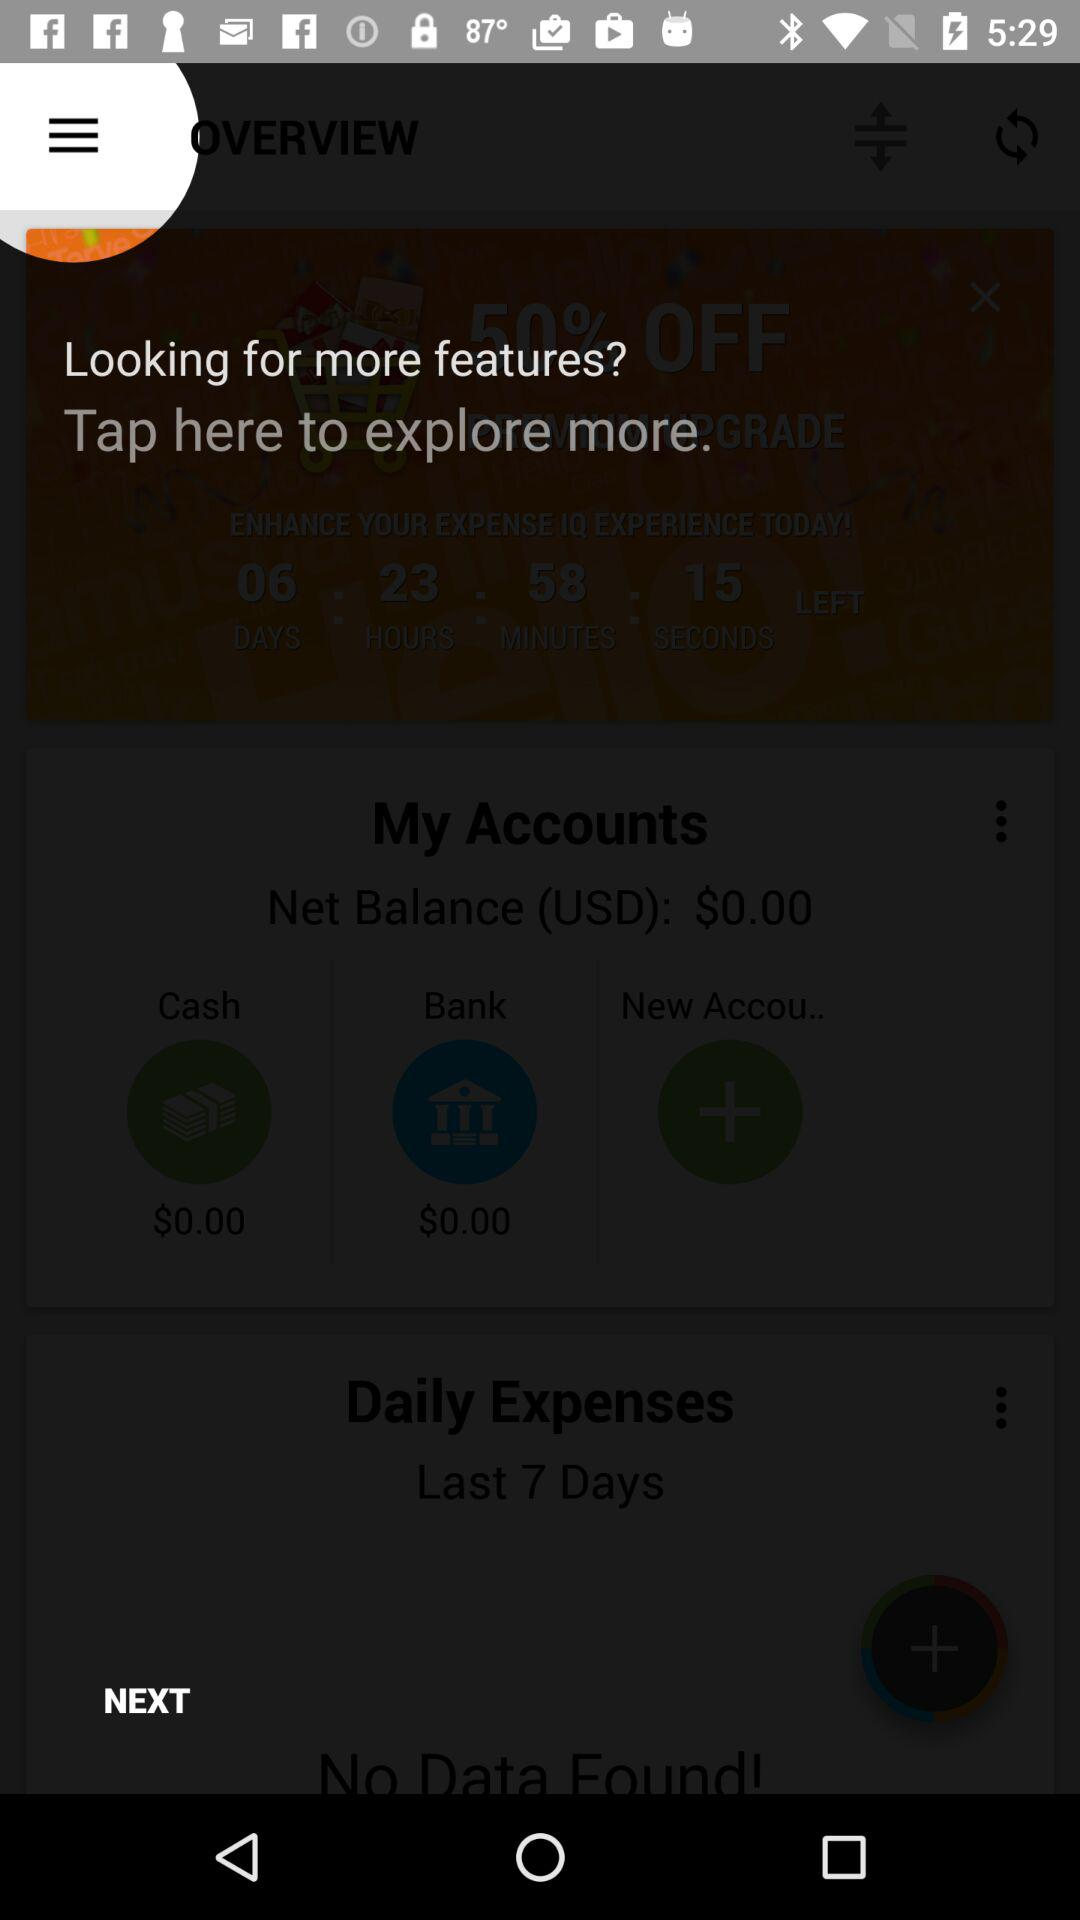What is the net cash balance? The net cash balance is $0. 